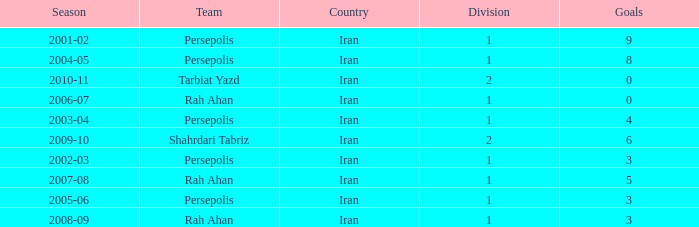What is the average Goals, when Team is "Rah Ahan", and when Division is less than 1? None. 